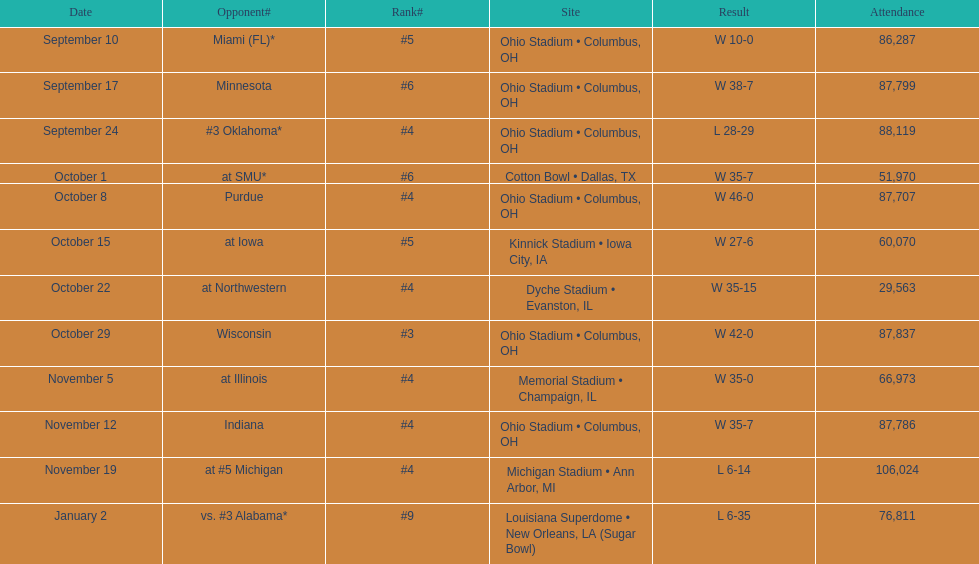What was the most recent game attended by less than 30,000 individuals? October 22. 